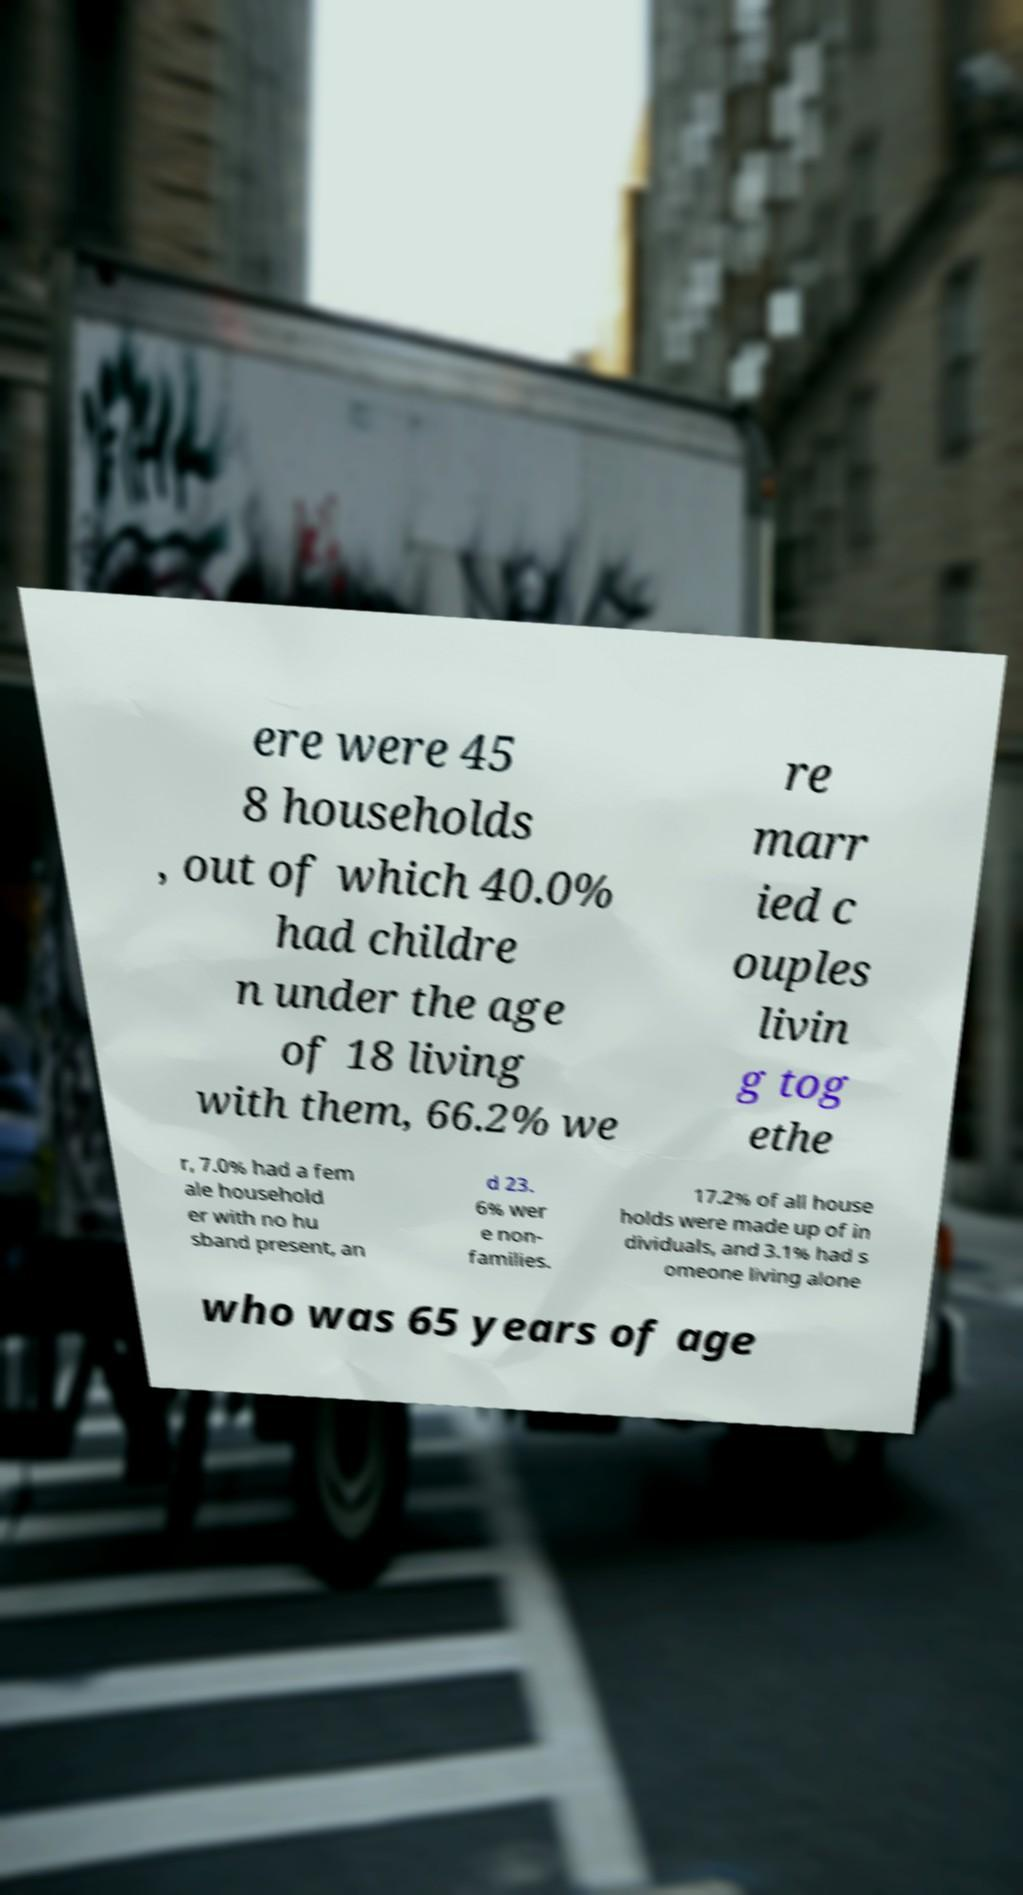Can you read and provide the text displayed in the image?This photo seems to have some interesting text. Can you extract and type it out for me? ere were 45 8 households , out of which 40.0% had childre n under the age of 18 living with them, 66.2% we re marr ied c ouples livin g tog ethe r, 7.0% had a fem ale household er with no hu sband present, an d 23. 6% wer e non- families. 17.2% of all house holds were made up of in dividuals, and 3.1% had s omeone living alone who was 65 years of age 